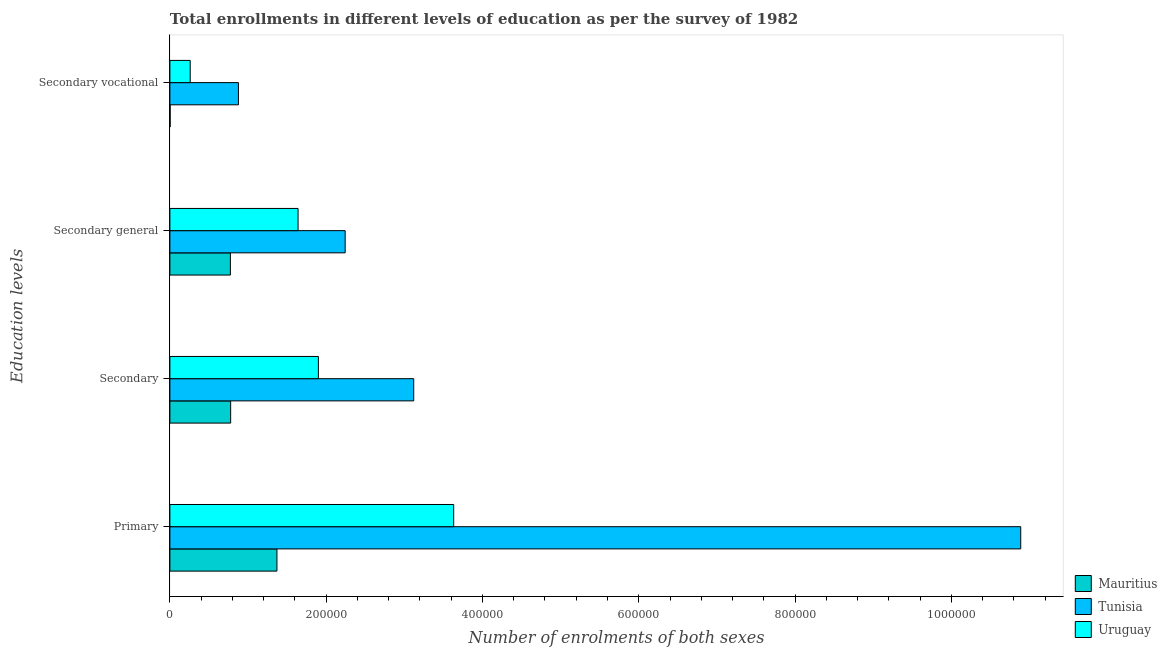How many different coloured bars are there?
Offer a very short reply. 3. How many groups of bars are there?
Offer a terse response. 4. What is the label of the 2nd group of bars from the top?
Provide a short and direct response. Secondary general. What is the number of enrolments in secondary vocational education in Tunisia?
Your response must be concise. 8.77e+04. Across all countries, what is the maximum number of enrolments in secondary education?
Offer a terse response. 3.12e+05. Across all countries, what is the minimum number of enrolments in primary education?
Your answer should be very brief. 1.37e+05. In which country was the number of enrolments in secondary vocational education maximum?
Your response must be concise. Tunisia. In which country was the number of enrolments in primary education minimum?
Offer a terse response. Mauritius. What is the total number of enrolments in secondary education in the graph?
Keep it short and to the point. 5.80e+05. What is the difference between the number of enrolments in secondary education in Uruguay and that in Mauritius?
Keep it short and to the point. 1.12e+05. What is the difference between the number of enrolments in secondary education in Tunisia and the number of enrolments in secondary general education in Mauritius?
Ensure brevity in your answer.  2.35e+05. What is the average number of enrolments in primary education per country?
Your answer should be compact. 5.30e+05. What is the difference between the number of enrolments in primary education and number of enrolments in secondary education in Mauritius?
Your answer should be compact. 5.92e+04. What is the ratio of the number of enrolments in secondary general education in Uruguay to that in Tunisia?
Provide a short and direct response. 0.73. Is the number of enrolments in secondary general education in Tunisia less than that in Uruguay?
Provide a succinct answer. No. Is the difference between the number of enrolments in secondary education in Tunisia and Uruguay greater than the difference between the number of enrolments in secondary vocational education in Tunisia and Uruguay?
Make the answer very short. Yes. What is the difference between the highest and the second highest number of enrolments in secondary vocational education?
Give a very brief answer. 6.17e+04. What is the difference between the highest and the lowest number of enrolments in secondary general education?
Keep it short and to the point. 1.47e+05. Is it the case that in every country, the sum of the number of enrolments in secondary education and number of enrolments in secondary vocational education is greater than the sum of number of enrolments in secondary general education and number of enrolments in primary education?
Provide a short and direct response. No. What does the 3rd bar from the top in Secondary vocational represents?
Your answer should be very brief. Mauritius. What does the 1st bar from the bottom in Secondary vocational represents?
Give a very brief answer. Mauritius. Are all the bars in the graph horizontal?
Your response must be concise. Yes. What is the difference between two consecutive major ticks on the X-axis?
Make the answer very short. 2.00e+05. Does the graph contain grids?
Provide a succinct answer. No. Where does the legend appear in the graph?
Keep it short and to the point. Bottom right. How are the legend labels stacked?
Provide a succinct answer. Vertical. What is the title of the graph?
Keep it short and to the point. Total enrollments in different levels of education as per the survey of 1982. What is the label or title of the X-axis?
Provide a short and direct response. Number of enrolments of both sexes. What is the label or title of the Y-axis?
Offer a very short reply. Education levels. What is the Number of enrolments of both sexes in Mauritius in Primary?
Keep it short and to the point. 1.37e+05. What is the Number of enrolments of both sexes of Tunisia in Primary?
Provide a succinct answer. 1.09e+06. What is the Number of enrolments of both sexes in Uruguay in Primary?
Offer a terse response. 3.63e+05. What is the Number of enrolments of both sexes in Mauritius in Secondary?
Your answer should be compact. 7.78e+04. What is the Number of enrolments of both sexes of Tunisia in Secondary?
Keep it short and to the point. 3.12e+05. What is the Number of enrolments of both sexes in Uruguay in Secondary?
Your answer should be very brief. 1.90e+05. What is the Number of enrolments of both sexes in Mauritius in Secondary general?
Make the answer very short. 7.74e+04. What is the Number of enrolments of both sexes in Tunisia in Secondary general?
Keep it short and to the point. 2.24e+05. What is the Number of enrolments of both sexes in Uruguay in Secondary general?
Your answer should be very brief. 1.64e+05. What is the Number of enrolments of both sexes in Mauritius in Secondary vocational?
Offer a terse response. 337. What is the Number of enrolments of both sexes in Tunisia in Secondary vocational?
Make the answer very short. 8.77e+04. What is the Number of enrolments of both sexes in Uruguay in Secondary vocational?
Make the answer very short. 2.60e+04. Across all Education levels, what is the maximum Number of enrolments of both sexes of Mauritius?
Offer a terse response. 1.37e+05. Across all Education levels, what is the maximum Number of enrolments of both sexes in Tunisia?
Offer a very short reply. 1.09e+06. Across all Education levels, what is the maximum Number of enrolments of both sexes of Uruguay?
Ensure brevity in your answer.  3.63e+05. Across all Education levels, what is the minimum Number of enrolments of both sexes in Mauritius?
Give a very brief answer. 337. Across all Education levels, what is the minimum Number of enrolments of both sexes in Tunisia?
Provide a short and direct response. 8.77e+04. Across all Education levels, what is the minimum Number of enrolments of both sexes of Uruguay?
Your answer should be compact. 2.60e+04. What is the total Number of enrolments of both sexes of Mauritius in the graph?
Offer a terse response. 2.93e+05. What is the total Number of enrolments of both sexes in Tunisia in the graph?
Your answer should be very brief. 1.71e+06. What is the total Number of enrolments of both sexes in Uruguay in the graph?
Your answer should be very brief. 7.43e+05. What is the difference between the Number of enrolments of both sexes of Mauritius in Primary and that in Secondary?
Offer a very short reply. 5.92e+04. What is the difference between the Number of enrolments of both sexes in Tunisia in Primary and that in Secondary?
Your response must be concise. 7.77e+05. What is the difference between the Number of enrolments of both sexes in Uruguay in Primary and that in Secondary?
Provide a succinct answer. 1.73e+05. What is the difference between the Number of enrolments of both sexes of Mauritius in Primary and that in Secondary general?
Provide a short and direct response. 5.96e+04. What is the difference between the Number of enrolments of both sexes in Tunisia in Primary and that in Secondary general?
Make the answer very short. 8.65e+05. What is the difference between the Number of enrolments of both sexes of Uruguay in Primary and that in Secondary general?
Your response must be concise. 1.99e+05. What is the difference between the Number of enrolments of both sexes in Mauritius in Primary and that in Secondary vocational?
Keep it short and to the point. 1.37e+05. What is the difference between the Number of enrolments of both sexes in Tunisia in Primary and that in Secondary vocational?
Give a very brief answer. 1.00e+06. What is the difference between the Number of enrolments of both sexes of Uruguay in Primary and that in Secondary vocational?
Make the answer very short. 3.37e+05. What is the difference between the Number of enrolments of both sexes in Mauritius in Secondary and that in Secondary general?
Your answer should be very brief. 337. What is the difference between the Number of enrolments of both sexes in Tunisia in Secondary and that in Secondary general?
Ensure brevity in your answer.  8.77e+04. What is the difference between the Number of enrolments of both sexes of Uruguay in Secondary and that in Secondary general?
Provide a short and direct response. 2.60e+04. What is the difference between the Number of enrolments of both sexes of Mauritius in Secondary and that in Secondary vocational?
Offer a very short reply. 7.74e+04. What is the difference between the Number of enrolments of both sexes of Tunisia in Secondary and that in Secondary vocational?
Ensure brevity in your answer.  2.24e+05. What is the difference between the Number of enrolments of both sexes in Uruguay in Secondary and that in Secondary vocational?
Your answer should be compact. 1.64e+05. What is the difference between the Number of enrolments of both sexes in Mauritius in Secondary general and that in Secondary vocational?
Offer a very short reply. 7.71e+04. What is the difference between the Number of enrolments of both sexes in Tunisia in Secondary general and that in Secondary vocational?
Make the answer very short. 1.37e+05. What is the difference between the Number of enrolments of both sexes in Uruguay in Secondary general and that in Secondary vocational?
Keep it short and to the point. 1.38e+05. What is the difference between the Number of enrolments of both sexes of Mauritius in Primary and the Number of enrolments of both sexes of Tunisia in Secondary?
Ensure brevity in your answer.  -1.75e+05. What is the difference between the Number of enrolments of both sexes in Mauritius in Primary and the Number of enrolments of both sexes in Uruguay in Secondary?
Your answer should be very brief. -5.30e+04. What is the difference between the Number of enrolments of both sexes in Tunisia in Primary and the Number of enrolments of both sexes in Uruguay in Secondary?
Your answer should be compact. 8.99e+05. What is the difference between the Number of enrolments of both sexes in Mauritius in Primary and the Number of enrolments of both sexes in Tunisia in Secondary general?
Make the answer very short. -8.73e+04. What is the difference between the Number of enrolments of both sexes in Mauritius in Primary and the Number of enrolments of both sexes in Uruguay in Secondary general?
Make the answer very short. -2.70e+04. What is the difference between the Number of enrolments of both sexes in Tunisia in Primary and the Number of enrolments of both sexes in Uruguay in Secondary general?
Keep it short and to the point. 9.25e+05. What is the difference between the Number of enrolments of both sexes in Mauritius in Primary and the Number of enrolments of both sexes in Tunisia in Secondary vocational?
Ensure brevity in your answer.  4.93e+04. What is the difference between the Number of enrolments of both sexes of Mauritius in Primary and the Number of enrolments of both sexes of Uruguay in Secondary vocational?
Your answer should be very brief. 1.11e+05. What is the difference between the Number of enrolments of both sexes in Tunisia in Primary and the Number of enrolments of both sexes in Uruguay in Secondary vocational?
Offer a terse response. 1.06e+06. What is the difference between the Number of enrolments of both sexes in Mauritius in Secondary and the Number of enrolments of both sexes in Tunisia in Secondary general?
Provide a short and direct response. -1.47e+05. What is the difference between the Number of enrolments of both sexes of Mauritius in Secondary and the Number of enrolments of both sexes of Uruguay in Secondary general?
Make the answer very short. -8.63e+04. What is the difference between the Number of enrolments of both sexes in Tunisia in Secondary and the Number of enrolments of both sexes in Uruguay in Secondary general?
Your answer should be very brief. 1.48e+05. What is the difference between the Number of enrolments of both sexes in Mauritius in Secondary and the Number of enrolments of both sexes in Tunisia in Secondary vocational?
Offer a very short reply. -9948. What is the difference between the Number of enrolments of both sexes in Mauritius in Secondary and the Number of enrolments of both sexes in Uruguay in Secondary vocational?
Offer a very short reply. 5.18e+04. What is the difference between the Number of enrolments of both sexes in Tunisia in Secondary and the Number of enrolments of both sexes in Uruguay in Secondary vocational?
Your response must be concise. 2.86e+05. What is the difference between the Number of enrolments of both sexes in Mauritius in Secondary general and the Number of enrolments of both sexes in Tunisia in Secondary vocational?
Provide a succinct answer. -1.03e+04. What is the difference between the Number of enrolments of both sexes in Mauritius in Secondary general and the Number of enrolments of both sexes in Uruguay in Secondary vocational?
Your answer should be very brief. 5.14e+04. What is the difference between the Number of enrolments of both sexes of Tunisia in Secondary general and the Number of enrolments of both sexes of Uruguay in Secondary vocational?
Your answer should be compact. 1.98e+05. What is the average Number of enrolments of both sexes of Mauritius per Education levels?
Make the answer very short. 7.31e+04. What is the average Number of enrolments of both sexes in Tunisia per Education levels?
Your answer should be compact. 4.28e+05. What is the average Number of enrolments of both sexes in Uruguay per Education levels?
Your response must be concise. 1.86e+05. What is the difference between the Number of enrolments of both sexes of Mauritius and Number of enrolments of both sexes of Tunisia in Primary?
Offer a terse response. -9.52e+05. What is the difference between the Number of enrolments of both sexes of Mauritius and Number of enrolments of both sexes of Uruguay in Primary?
Your answer should be very brief. -2.26e+05. What is the difference between the Number of enrolments of both sexes in Tunisia and Number of enrolments of both sexes in Uruguay in Primary?
Your answer should be compact. 7.26e+05. What is the difference between the Number of enrolments of both sexes of Mauritius and Number of enrolments of both sexes of Tunisia in Secondary?
Make the answer very short. -2.34e+05. What is the difference between the Number of enrolments of both sexes of Mauritius and Number of enrolments of both sexes of Uruguay in Secondary?
Keep it short and to the point. -1.12e+05. What is the difference between the Number of enrolments of both sexes of Tunisia and Number of enrolments of both sexes of Uruguay in Secondary?
Your answer should be compact. 1.22e+05. What is the difference between the Number of enrolments of both sexes of Mauritius and Number of enrolments of both sexes of Tunisia in Secondary general?
Your answer should be compact. -1.47e+05. What is the difference between the Number of enrolments of both sexes in Mauritius and Number of enrolments of both sexes in Uruguay in Secondary general?
Your answer should be very brief. -8.66e+04. What is the difference between the Number of enrolments of both sexes in Tunisia and Number of enrolments of both sexes in Uruguay in Secondary general?
Ensure brevity in your answer.  6.03e+04. What is the difference between the Number of enrolments of both sexes of Mauritius and Number of enrolments of both sexes of Tunisia in Secondary vocational?
Ensure brevity in your answer.  -8.74e+04. What is the difference between the Number of enrolments of both sexes in Mauritius and Number of enrolments of both sexes in Uruguay in Secondary vocational?
Provide a succinct answer. -2.57e+04. What is the difference between the Number of enrolments of both sexes in Tunisia and Number of enrolments of both sexes in Uruguay in Secondary vocational?
Give a very brief answer. 6.17e+04. What is the ratio of the Number of enrolments of both sexes of Mauritius in Primary to that in Secondary?
Ensure brevity in your answer.  1.76. What is the ratio of the Number of enrolments of both sexes of Tunisia in Primary to that in Secondary?
Provide a succinct answer. 3.49. What is the ratio of the Number of enrolments of both sexes of Uruguay in Primary to that in Secondary?
Your answer should be very brief. 1.91. What is the ratio of the Number of enrolments of both sexes of Mauritius in Primary to that in Secondary general?
Ensure brevity in your answer.  1.77. What is the ratio of the Number of enrolments of both sexes of Tunisia in Primary to that in Secondary general?
Your answer should be very brief. 4.85. What is the ratio of the Number of enrolments of both sexes in Uruguay in Primary to that in Secondary general?
Keep it short and to the point. 2.21. What is the ratio of the Number of enrolments of both sexes of Mauritius in Primary to that in Secondary vocational?
Provide a succinct answer. 406.54. What is the ratio of the Number of enrolments of both sexes in Tunisia in Primary to that in Secondary vocational?
Provide a succinct answer. 12.41. What is the ratio of the Number of enrolments of both sexes of Uruguay in Primary to that in Secondary vocational?
Give a very brief answer. 13.96. What is the ratio of the Number of enrolments of both sexes of Tunisia in Secondary to that in Secondary general?
Make the answer very short. 1.39. What is the ratio of the Number of enrolments of both sexes in Uruguay in Secondary to that in Secondary general?
Keep it short and to the point. 1.16. What is the ratio of the Number of enrolments of both sexes in Mauritius in Secondary to that in Secondary vocational?
Your answer should be compact. 230.8. What is the ratio of the Number of enrolments of both sexes of Tunisia in Secondary to that in Secondary vocational?
Keep it short and to the point. 3.56. What is the ratio of the Number of enrolments of both sexes in Uruguay in Secondary to that in Secondary vocational?
Make the answer very short. 7.3. What is the ratio of the Number of enrolments of both sexes of Mauritius in Secondary general to that in Secondary vocational?
Offer a terse response. 229.8. What is the ratio of the Number of enrolments of both sexes in Tunisia in Secondary general to that in Secondary vocational?
Provide a succinct answer. 2.56. What is the ratio of the Number of enrolments of both sexes of Uruguay in Secondary general to that in Secondary vocational?
Give a very brief answer. 6.3. What is the difference between the highest and the second highest Number of enrolments of both sexes in Mauritius?
Make the answer very short. 5.92e+04. What is the difference between the highest and the second highest Number of enrolments of both sexes in Tunisia?
Your answer should be very brief. 7.77e+05. What is the difference between the highest and the second highest Number of enrolments of both sexes in Uruguay?
Ensure brevity in your answer.  1.73e+05. What is the difference between the highest and the lowest Number of enrolments of both sexes of Mauritius?
Provide a short and direct response. 1.37e+05. What is the difference between the highest and the lowest Number of enrolments of both sexes of Tunisia?
Your answer should be very brief. 1.00e+06. What is the difference between the highest and the lowest Number of enrolments of both sexes in Uruguay?
Your response must be concise. 3.37e+05. 